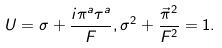Convert formula to latex. <formula><loc_0><loc_0><loc_500><loc_500>U = \sigma + \frac { i \pi ^ { a } \tau ^ { a } } { F } , \sigma ^ { 2 } + \frac { \vec { \pi } ^ { 2 } } { F ^ { 2 } } = 1 .</formula> 